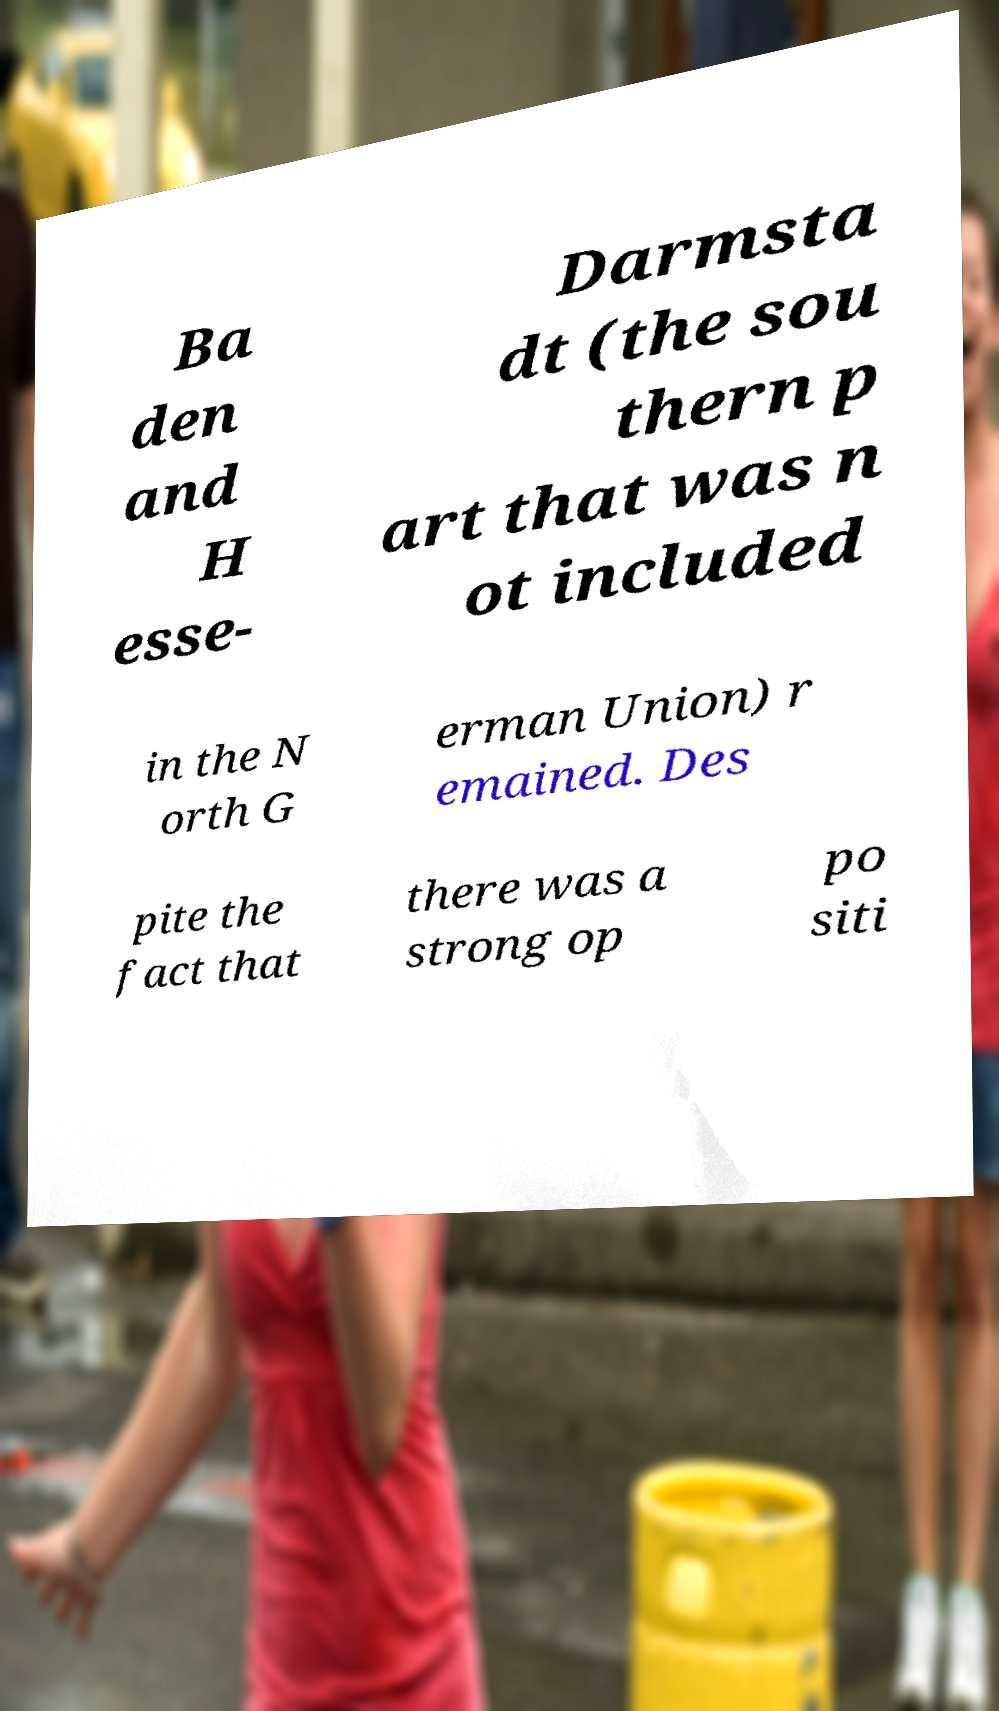What messages or text are displayed in this image? I need them in a readable, typed format. Ba den and H esse- Darmsta dt (the sou thern p art that was n ot included in the N orth G erman Union) r emained. Des pite the fact that there was a strong op po siti 